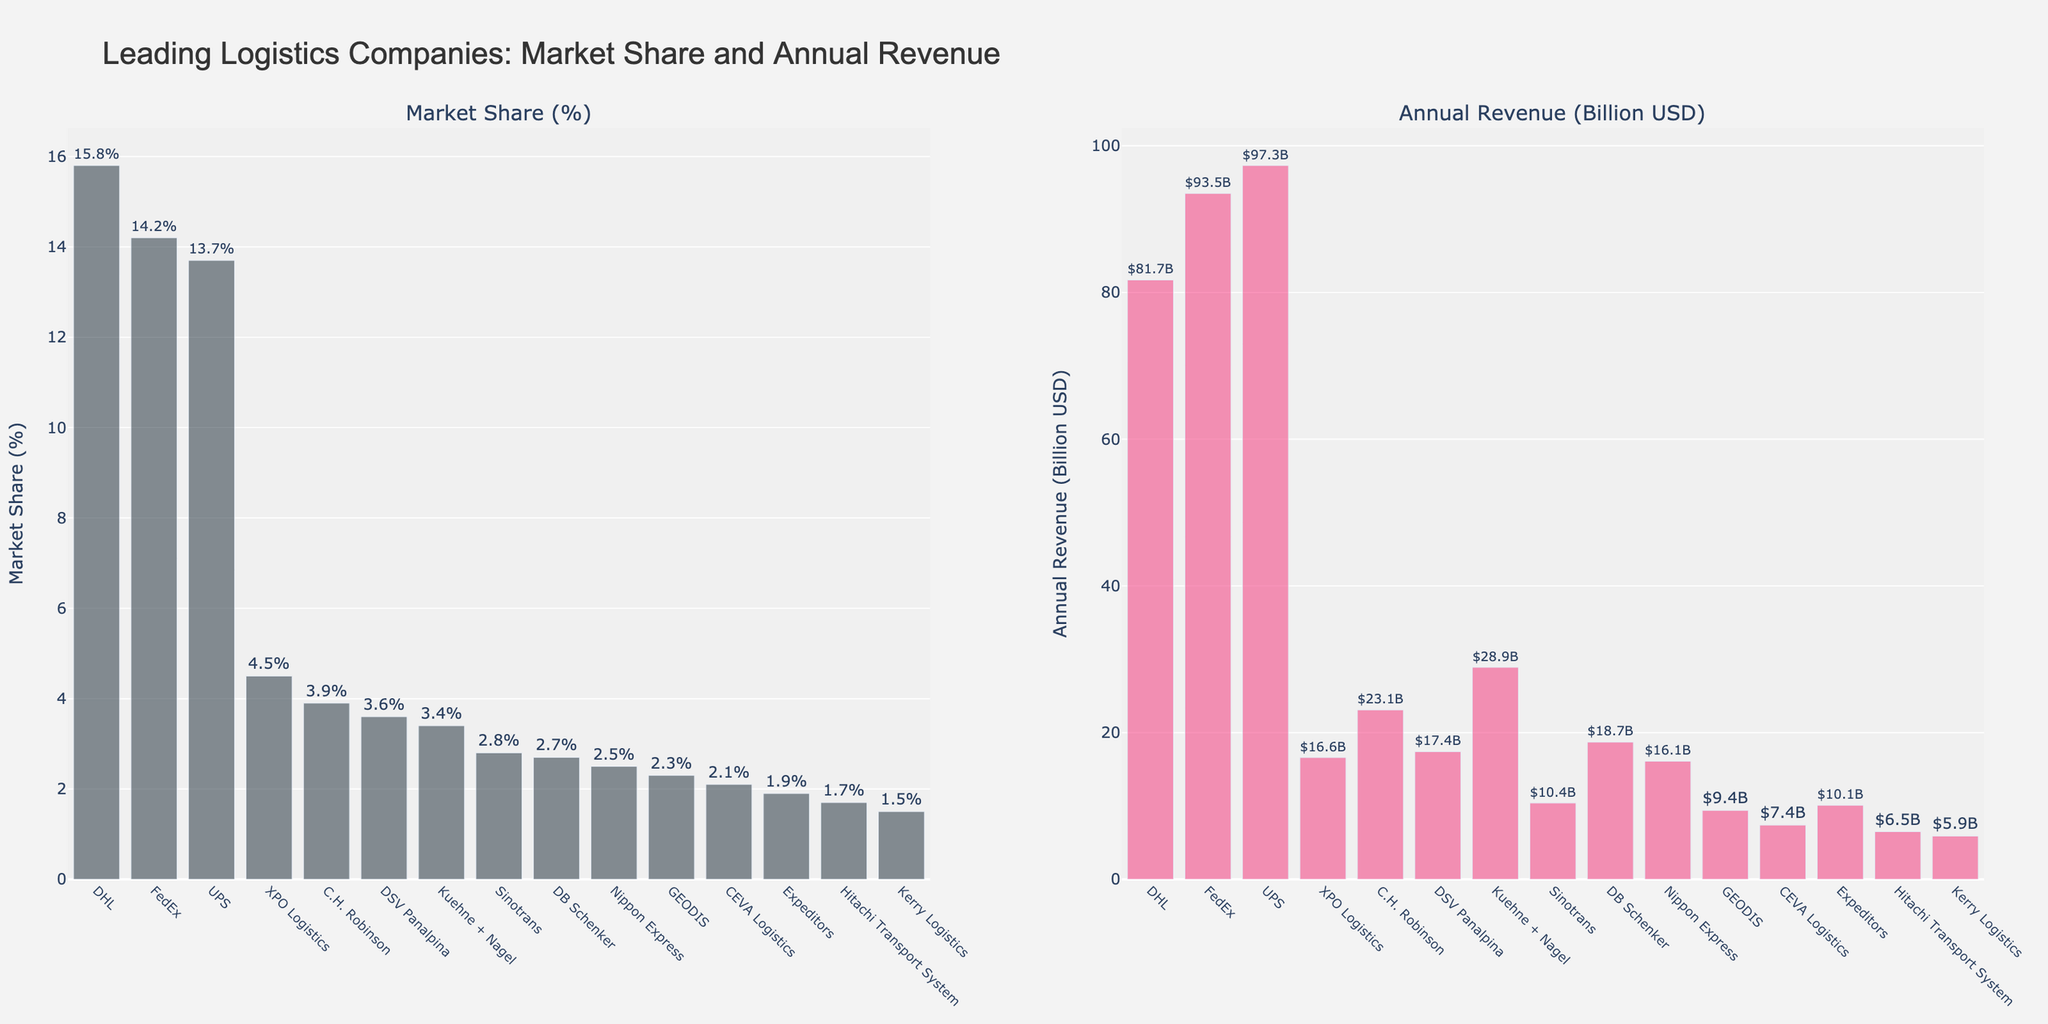Which company has the highest market share? By examining the bar on the Market Share subplot, it’s clear that DHL has the highest bar, indicating the largest market share at 15.8%.
Answer: DHL Which company has the lowest annual revenue? By looking at the Annual Revenue subplot, the bar for Kerry Logistics is the shortest, indicating the lowest annual revenue at $5.9 billion.
Answer: Kerry Logistics How much greater is the annual revenue of UPS compared to GEODIS? From the Annual Revenue subplot, UPS has an annual revenue of $97.3 billion and GEODIS has $9.4 billion. The difference is $97.3B - $9.4B = $87.9B.
Answer: $87.9 billion Which two companies have the closest market share percentages? By comparing the lengths of the bars in the Market Share subplot, DSV Panalpina and Kuehne + Nagel have similar lengths. Their market shares are 3.6% and 3.4%, respectively, making a difference of 0.2%.
Answer: DSV Panalpina and Kuehne + Nagel How many companies have a market share of less than 3%? From the Market Share subplot, the companies with bars showing market shares below 3% are Sinotrans, DB Schenker, Nippon Express, GEODIS, CEVA Logistics, Expeditors, Hitachi Transport System, and Kerry Logistics, which total 8 companies.
Answer: 8 What is the total market share of the top three companies? The Market Share subplot shows the top three companies as DHL (15.8%), FedEx (14.2%), and UPS (13.7%). Their total market share is 15.8% + 14.2% + 13.7% = 43.7%.
Answer: 43.7% Which company has a higher market share: DB Schenker or Expeditors? DB Schenker has a market share of 2.7%, whereas Expeditors has a market share of 1.9%, as shown by the heights of their bars in the Market Share subplot.
Answer: DB Schenker What is the median annual revenue of all the companies listed? To find the median value, list the annual revenues in ascending order: 5.9, 6.5, 7.4, 9.4, 10.1, 10.4, 16.1, 16.6, 17.4, 18.7, 23.1, 28.9, 81.7, 93.5, 97.3. The middle value in the ordered list, or the 8th value, is 16.6 billion USD.
Answer: $16.6 billion Between DHL and FedEx, which company has the higher annual revenue? By examining the bar heights in the Annual Revenue subplot, FedEx has a higher annual revenue ($93.5 billion) compared to DHL ($81.7 billion).
Answer: FedEx 